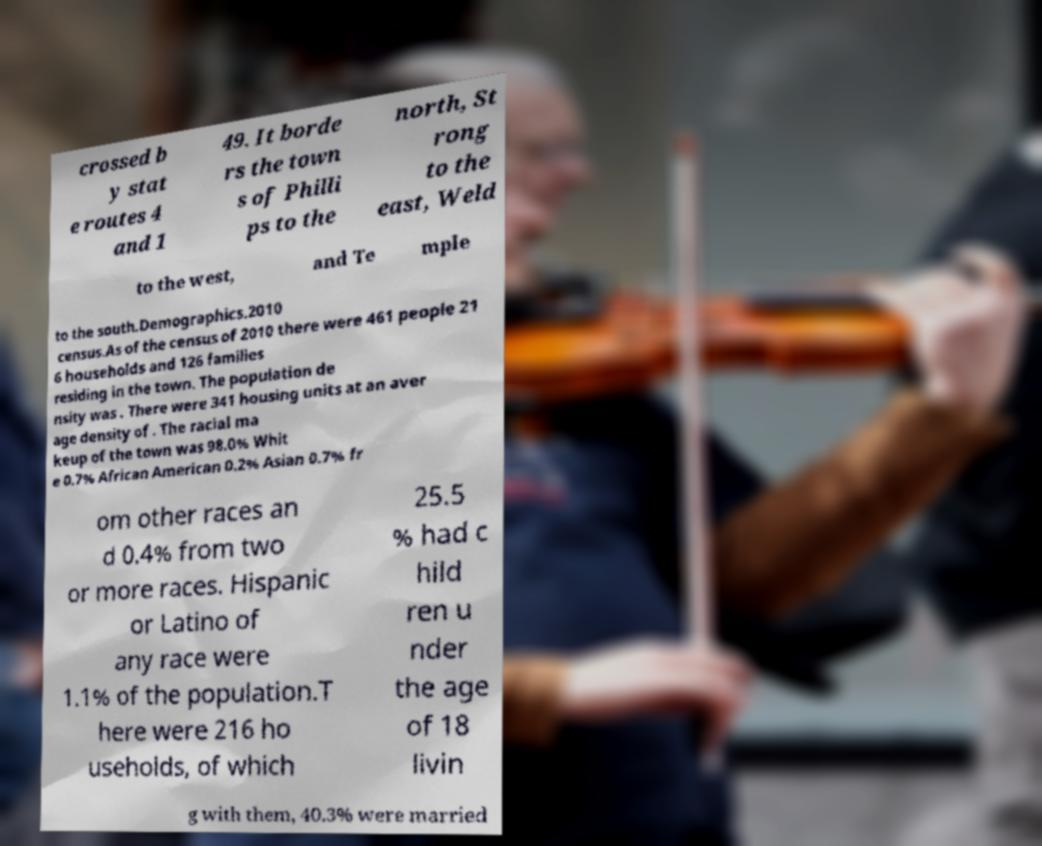Please identify and transcribe the text found in this image. crossed b y stat e routes 4 and 1 49. It borde rs the town s of Philli ps to the north, St rong to the east, Weld to the west, and Te mple to the south.Demographics.2010 census.As of the census of 2010 there were 461 people 21 6 households and 126 families residing in the town. The population de nsity was . There were 341 housing units at an aver age density of . The racial ma keup of the town was 98.0% Whit e 0.7% African American 0.2% Asian 0.7% fr om other races an d 0.4% from two or more races. Hispanic or Latino of any race were 1.1% of the population.T here were 216 ho useholds, of which 25.5 % had c hild ren u nder the age of 18 livin g with them, 40.3% were married 